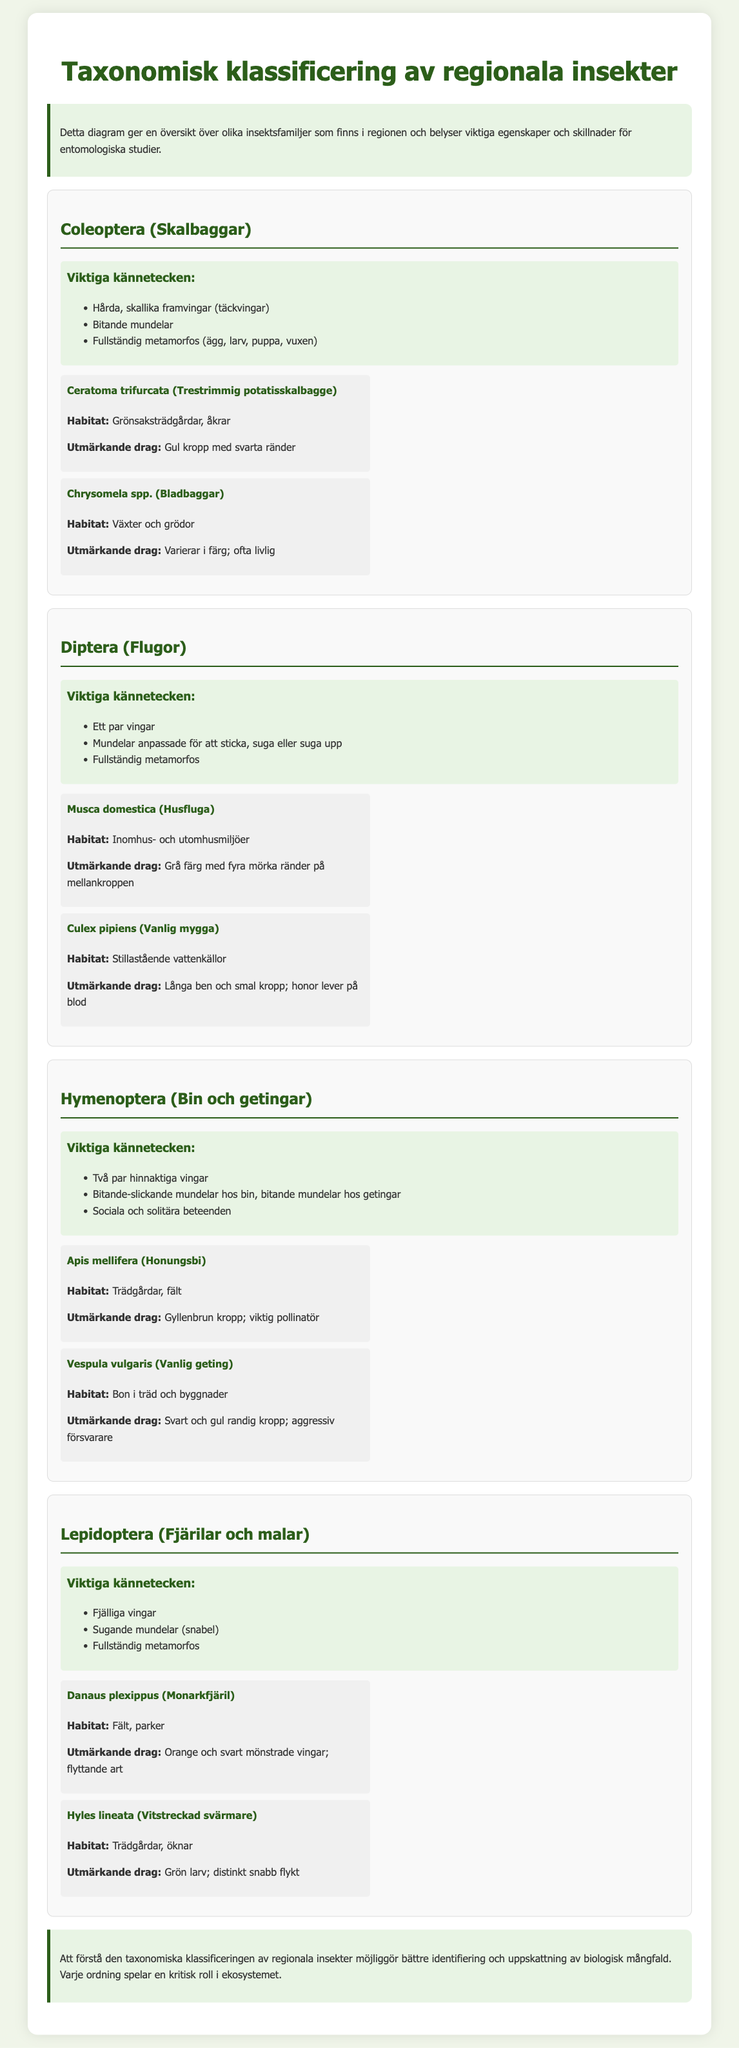Vad är det latinska namnet för vanliga myggan? Det latinska namnet för vanliga myggan anges som Culex pipiens i dokumentet.
Answer: Culex pipiens Vilken insekt har hårda, skallika framvingar? Insekten som har hårda, skallika framvingar beskrivs i dokumentet som Skalbaggar (Coleoptera).
Answer: Skalbaggar Vad är en karakteristisk egenskap hos fjärilar och malar? En karakteristisk egenskap för fjärilar och malar (Lepidoptera) är fjälliga vingar.
Answer: Fjälliga vingar Vilken insekt är en viktig pollinatör? Insekten som anges som en viktig pollinatör är Honungsbi (Apis mellifera).
Answer: Honungsbi Hur många insektsordningar presenteras i dokumentet? Dokumentet presenterar fyra insektsordningar: Coleoptera, Diptera, Hymenoptera och Lepidoptera.
Answer: Fyra Vilken typ av mundelar har getingar enligt dokumentet? Enligt dokumentet har getingar bitande mundelar.
Answer: Bitande Vilken insekt har orange och svart mönstrade vingar? Insekten med orange och svart mönstrade vingar är Monarkfjäril (Danaus plexippus).
Answer: Monarkfjäril Vilken habitat är vanlig för husflugan? Den habitat som anges för husflugan är inomhus- och utomhusmiljöer.
Answer: Inomhus- och utomhusmiljöer 